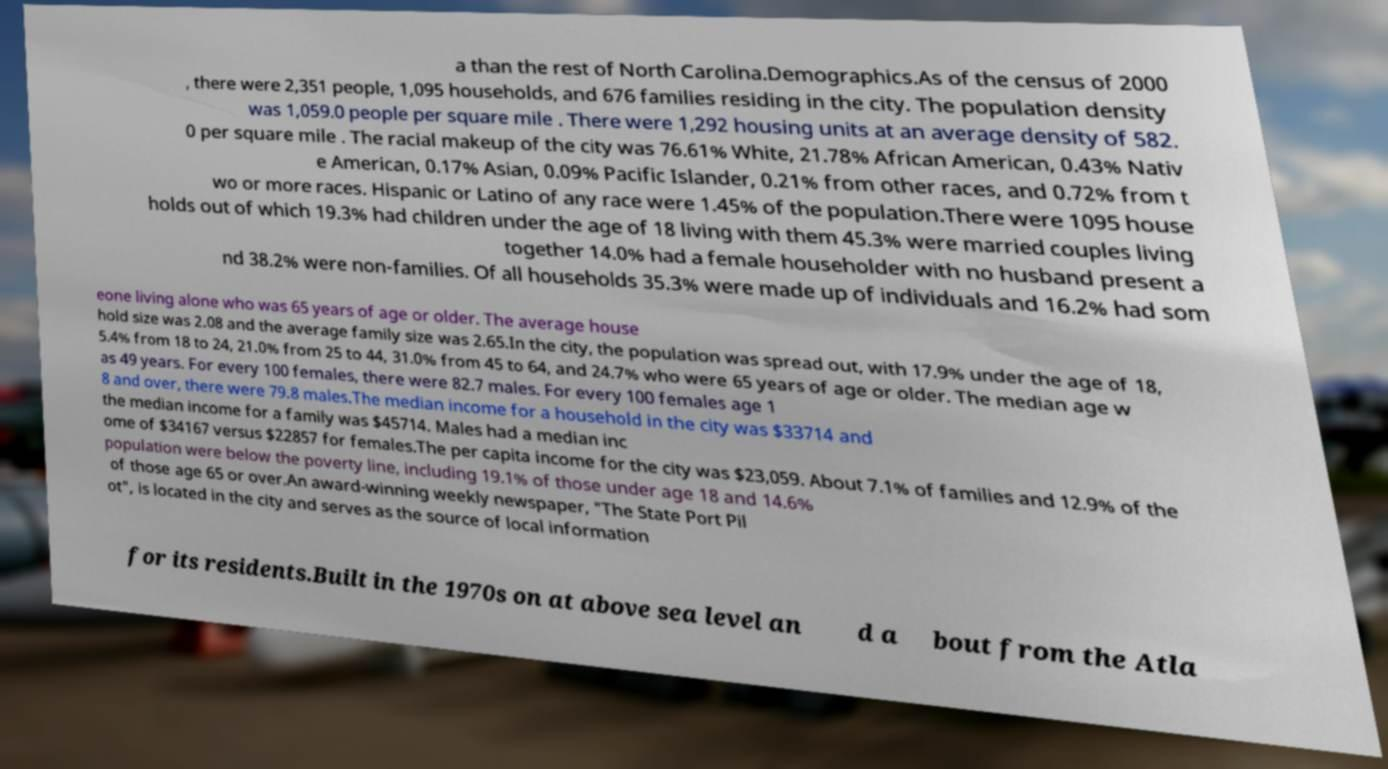What messages or text are displayed in this image? I need them in a readable, typed format. a than the rest of North Carolina.Demographics.As of the census of 2000 , there were 2,351 people, 1,095 households, and 676 families residing in the city. The population density was 1,059.0 people per square mile . There were 1,292 housing units at an average density of 582. 0 per square mile . The racial makeup of the city was 76.61% White, 21.78% African American, 0.43% Nativ e American, 0.17% Asian, 0.09% Pacific Islander, 0.21% from other races, and 0.72% from t wo or more races. Hispanic or Latino of any race were 1.45% of the population.There were 1095 house holds out of which 19.3% had children under the age of 18 living with them 45.3% were married couples living together 14.0% had a female householder with no husband present a nd 38.2% were non-families. Of all households 35.3% were made up of individuals and 16.2% had som eone living alone who was 65 years of age or older. The average house hold size was 2.08 and the average family size was 2.65.In the city, the population was spread out, with 17.9% under the age of 18, 5.4% from 18 to 24, 21.0% from 25 to 44, 31.0% from 45 to 64, and 24.7% who were 65 years of age or older. The median age w as 49 years. For every 100 females, there were 82.7 males. For every 100 females age 1 8 and over, there were 79.8 males.The median income for a household in the city was $33714 and the median income for a family was $45714. Males had a median inc ome of $34167 versus $22857 for females.The per capita income for the city was $23,059. About 7.1% of families and 12.9% of the population were below the poverty line, including 19.1% of those under age 18 and 14.6% of those age 65 or over.An award-winning weekly newspaper, "The State Port Pil ot", is located in the city and serves as the source of local information for its residents.Built in the 1970s on at above sea level an d a bout from the Atla 